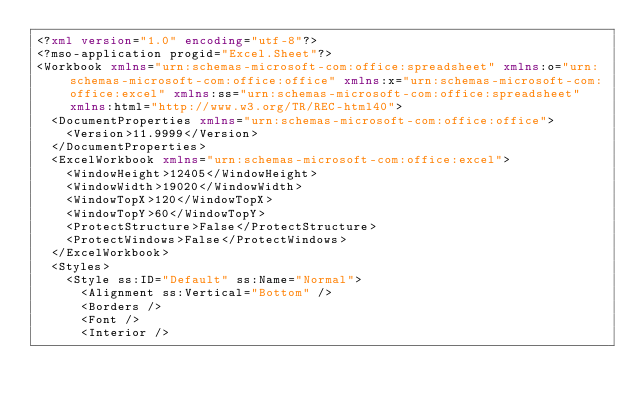Convert code to text. <code><loc_0><loc_0><loc_500><loc_500><_XML_><?xml version="1.0" encoding="utf-8"?>
<?mso-application progid="Excel.Sheet"?>
<Workbook xmlns="urn:schemas-microsoft-com:office:spreadsheet" xmlns:o="urn:schemas-microsoft-com:office:office" xmlns:x="urn:schemas-microsoft-com:office:excel" xmlns:ss="urn:schemas-microsoft-com:office:spreadsheet" xmlns:html="http://www.w3.org/TR/REC-html40">
  <DocumentProperties xmlns="urn:schemas-microsoft-com:office:office">
    <Version>11.9999</Version>
  </DocumentProperties>
  <ExcelWorkbook xmlns="urn:schemas-microsoft-com:office:excel">
    <WindowHeight>12405</WindowHeight>
    <WindowWidth>19020</WindowWidth>
    <WindowTopX>120</WindowTopX>
    <WindowTopY>60</WindowTopY>
    <ProtectStructure>False</ProtectStructure>
    <ProtectWindows>False</ProtectWindows>
  </ExcelWorkbook>
  <Styles>
    <Style ss:ID="Default" ss:Name="Normal">
      <Alignment ss:Vertical="Bottom" />
      <Borders />
      <Font />
      <Interior /></code> 